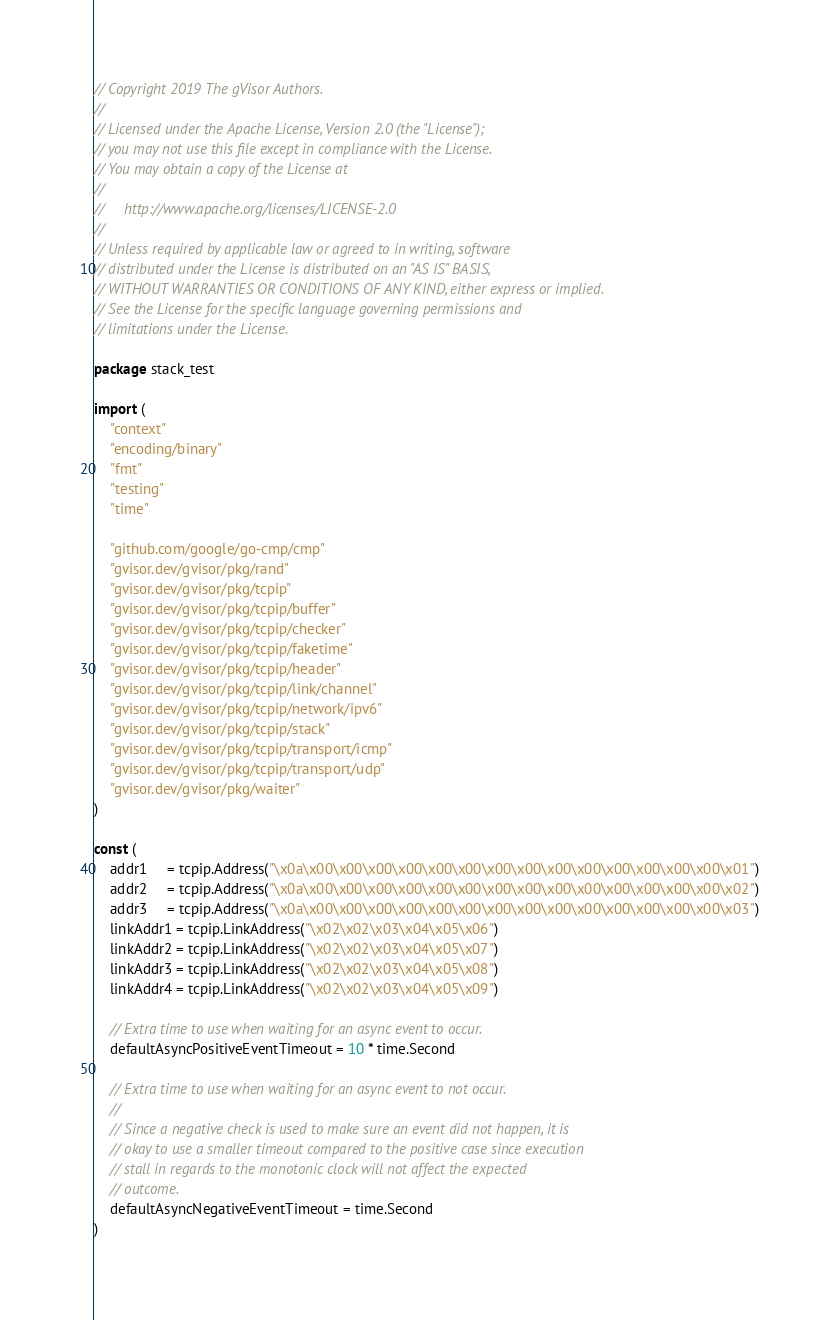Convert code to text. <code><loc_0><loc_0><loc_500><loc_500><_Go_>// Copyright 2019 The gVisor Authors.
//
// Licensed under the Apache License, Version 2.0 (the "License");
// you may not use this file except in compliance with the License.
// You may obtain a copy of the License at
//
//     http://www.apache.org/licenses/LICENSE-2.0
//
// Unless required by applicable law or agreed to in writing, software
// distributed under the License is distributed on an "AS IS" BASIS,
// WITHOUT WARRANTIES OR CONDITIONS OF ANY KIND, either express or implied.
// See the License for the specific language governing permissions and
// limitations under the License.

package stack_test

import (
	"context"
	"encoding/binary"
	"fmt"
	"testing"
	"time"

	"github.com/google/go-cmp/cmp"
	"gvisor.dev/gvisor/pkg/rand"
	"gvisor.dev/gvisor/pkg/tcpip"
	"gvisor.dev/gvisor/pkg/tcpip/buffer"
	"gvisor.dev/gvisor/pkg/tcpip/checker"
	"gvisor.dev/gvisor/pkg/tcpip/faketime"
	"gvisor.dev/gvisor/pkg/tcpip/header"
	"gvisor.dev/gvisor/pkg/tcpip/link/channel"
	"gvisor.dev/gvisor/pkg/tcpip/network/ipv6"
	"gvisor.dev/gvisor/pkg/tcpip/stack"
	"gvisor.dev/gvisor/pkg/tcpip/transport/icmp"
	"gvisor.dev/gvisor/pkg/tcpip/transport/udp"
	"gvisor.dev/gvisor/pkg/waiter"
)

const (
	addr1     = tcpip.Address("\x0a\x00\x00\x00\x00\x00\x00\x00\x00\x00\x00\x00\x00\x00\x00\x01")
	addr2     = tcpip.Address("\x0a\x00\x00\x00\x00\x00\x00\x00\x00\x00\x00\x00\x00\x00\x00\x02")
	addr3     = tcpip.Address("\x0a\x00\x00\x00\x00\x00\x00\x00\x00\x00\x00\x00\x00\x00\x00\x03")
	linkAddr1 = tcpip.LinkAddress("\x02\x02\x03\x04\x05\x06")
	linkAddr2 = tcpip.LinkAddress("\x02\x02\x03\x04\x05\x07")
	linkAddr3 = tcpip.LinkAddress("\x02\x02\x03\x04\x05\x08")
	linkAddr4 = tcpip.LinkAddress("\x02\x02\x03\x04\x05\x09")

	// Extra time to use when waiting for an async event to occur.
	defaultAsyncPositiveEventTimeout = 10 * time.Second

	// Extra time to use when waiting for an async event to not occur.
	//
	// Since a negative check is used to make sure an event did not happen, it is
	// okay to use a smaller timeout compared to the positive case since execution
	// stall in regards to the monotonic clock will not affect the expected
	// outcome.
	defaultAsyncNegativeEventTimeout = time.Second
)
</code> 